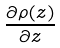Convert formula to latex. <formula><loc_0><loc_0><loc_500><loc_500>\frac { \partial \rho ( z ) } { \partial z }</formula> 